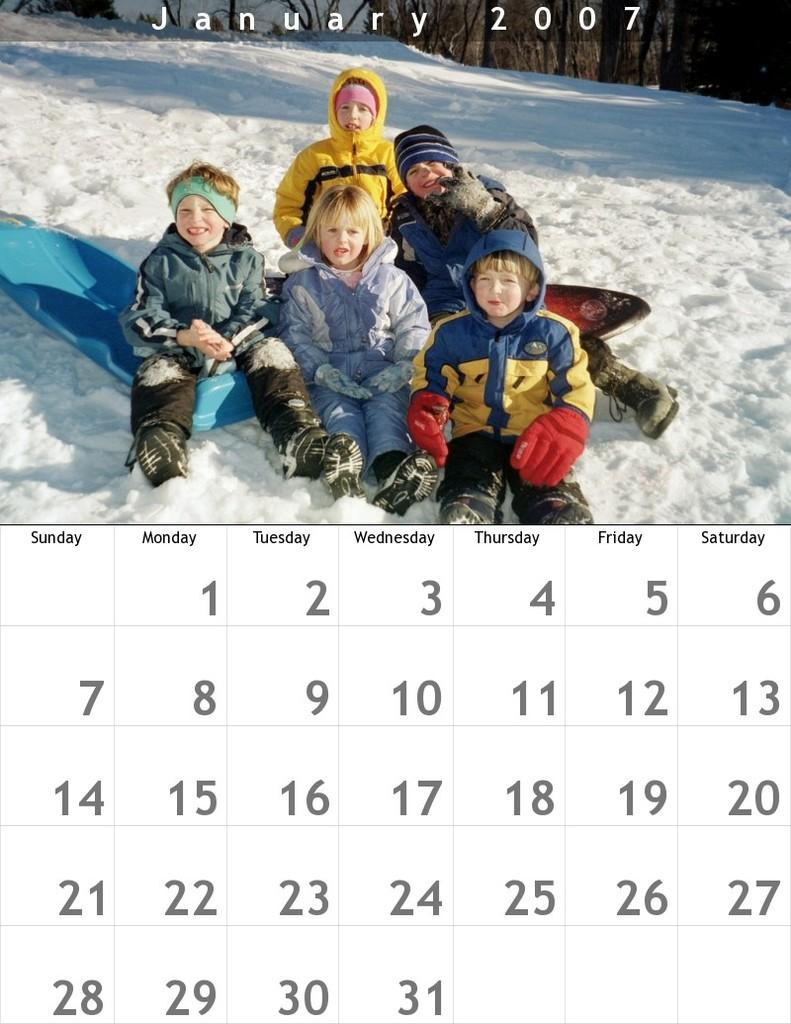What is one of the objects in the image? There is a calendar in the image. What else can be seen in the image besides the calendar? There is a picture in the image. What is depicted in the picture? The picture contains persons. What is the weather like in the picture? There is snow on the ground in the picture. What type of celery can be seen growing in the image? There is no celery present in the image. Can you describe the detail of the pet in the image? There is no pet present in the image. 